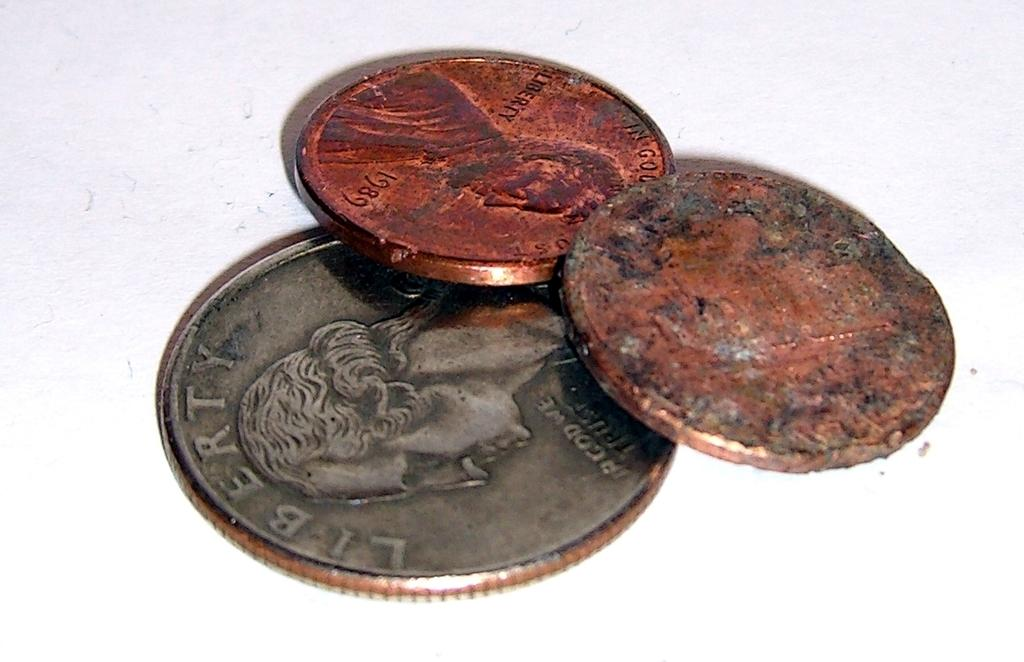<image>
Provide a brief description of the given image. A silver coin that says Liberty is under two rusty pennies. 